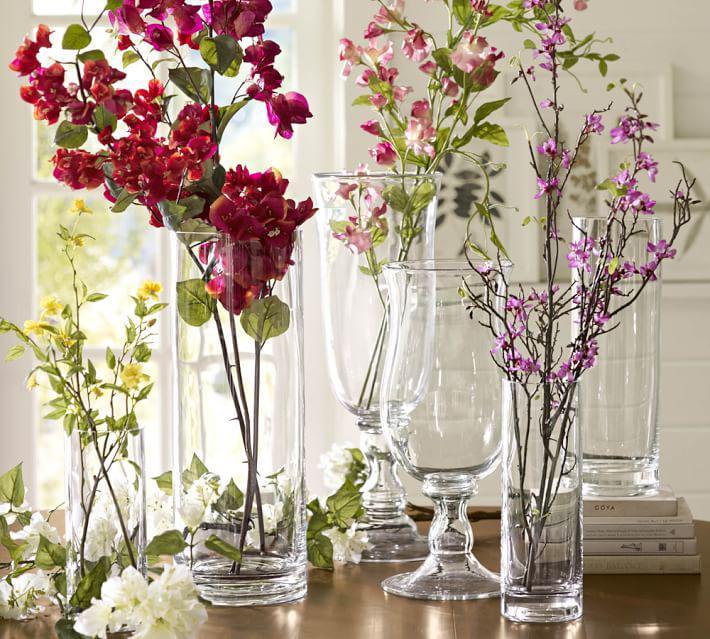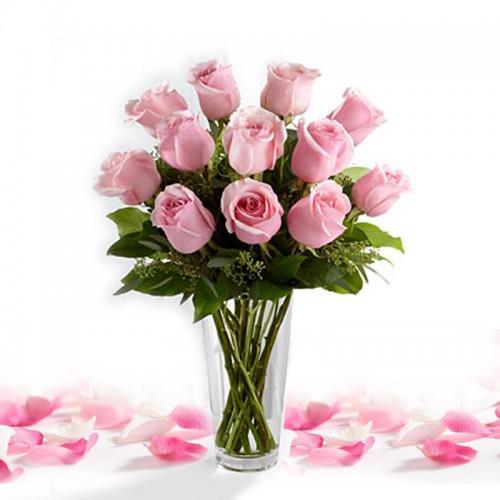The first image is the image on the left, the second image is the image on the right. For the images shown, is this caption "One of the images contains white flowers" true? Answer yes or no. No. 